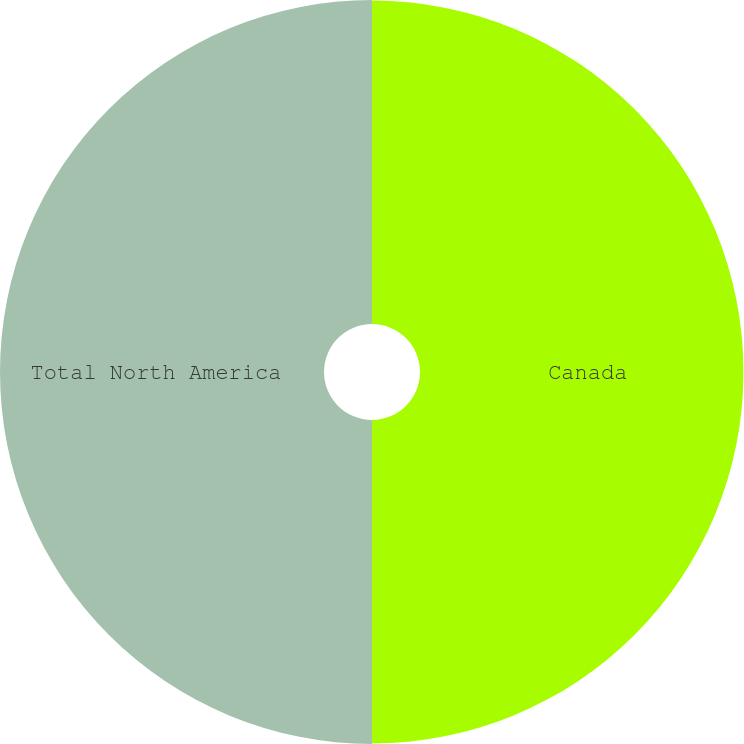Convert chart to OTSL. <chart><loc_0><loc_0><loc_500><loc_500><pie_chart><fcel>Canada<fcel>Total North America<nl><fcel>49.96%<fcel>50.04%<nl></chart> 